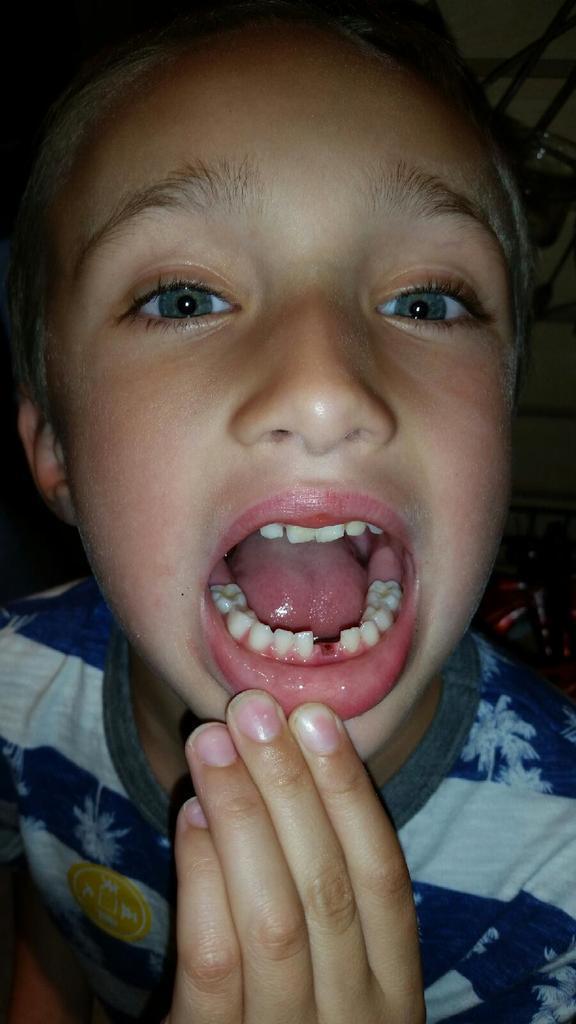Could you give a brief overview of what you see in this image? In this image we can see a person with open mouth. And at the back there are few objects. 